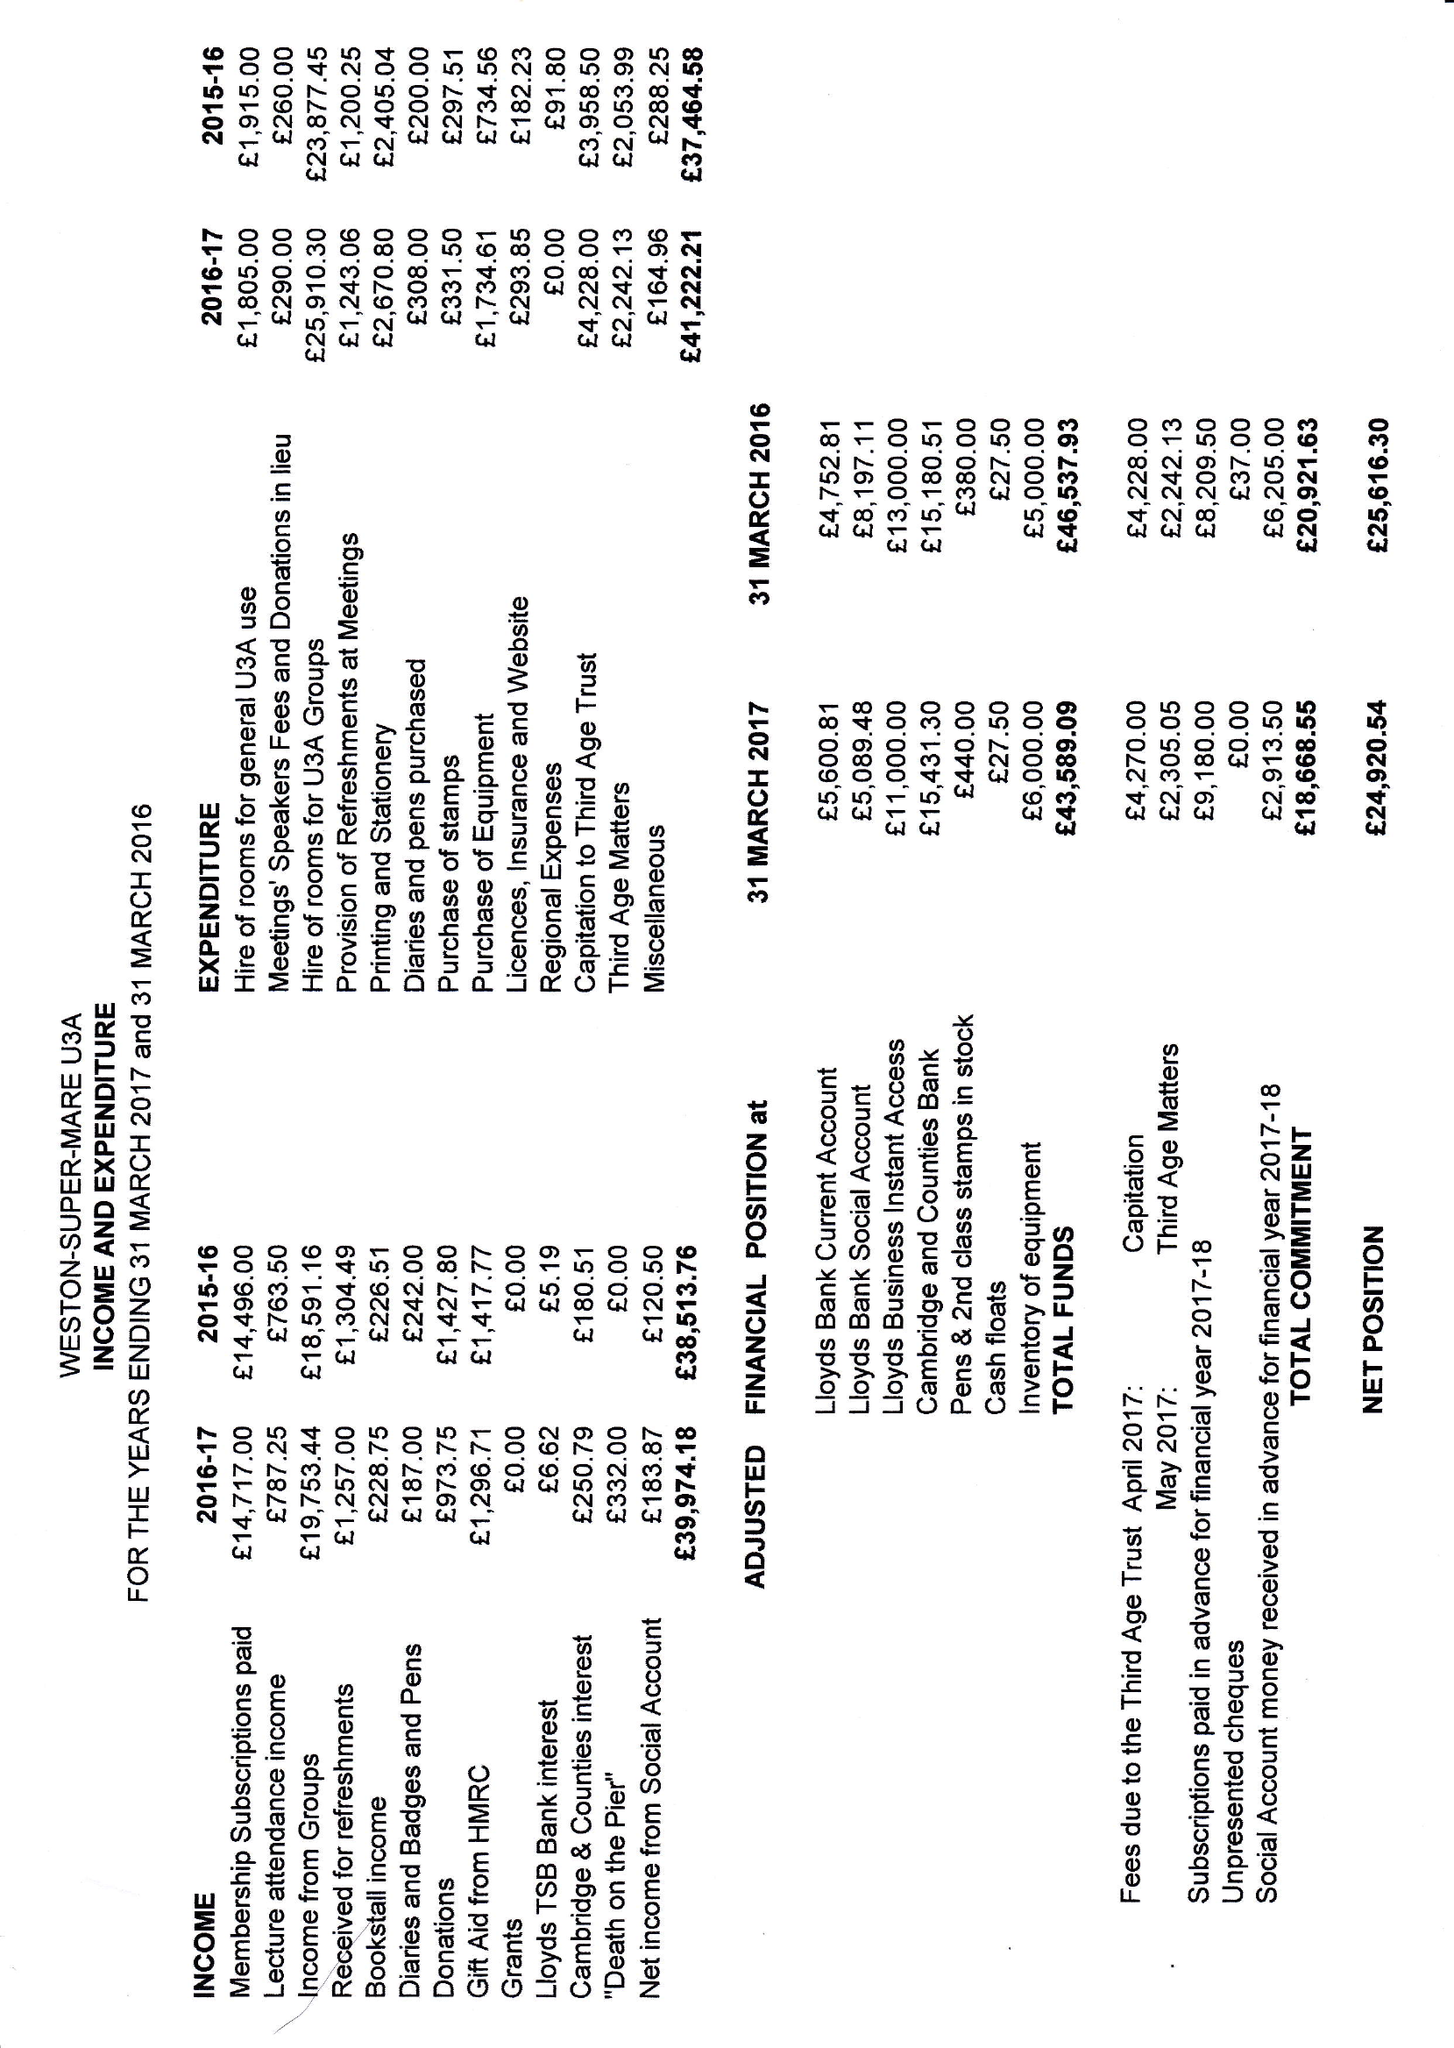What is the value for the spending_annually_in_british_pounds?
Answer the question using a single word or phrase. 41222.00 